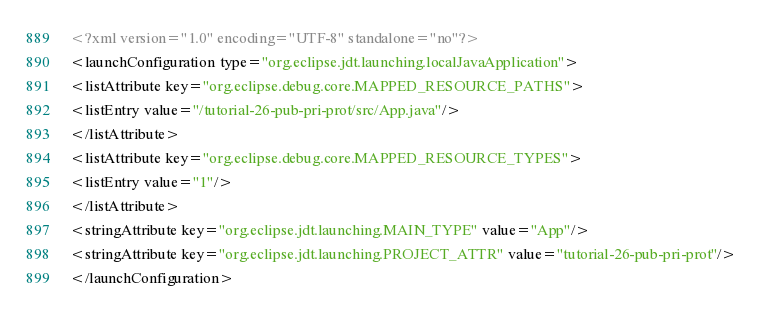Convert code to text. <code><loc_0><loc_0><loc_500><loc_500><_XML_><?xml version="1.0" encoding="UTF-8" standalone="no"?>
<launchConfiguration type="org.eclipse.jdt.launching.localJavaApplication">
<listAttribute key="org.eclipse.debug.core.MAPPED_RESOURCE_PATHS">
<listEntry value="/tutorial-26-pub-pri-prot/src/App.java"/>
</listAttribute>
<listAttribute key="org.eclipse.debug.core.MAPPED_RESOURCE_TYPES">
<listEntry value="1"/>
</listAttribute>
<stringAttribute key="org.eclipse.jdt.launching.MAIN_TYPE" value="App"/>
<stringAttribute key="org.eclipse.jdt.launching.PROJECT_ATTR" value="tutorial-26-pub-pri-prot"/>
</launchConfiguration>
</code> 